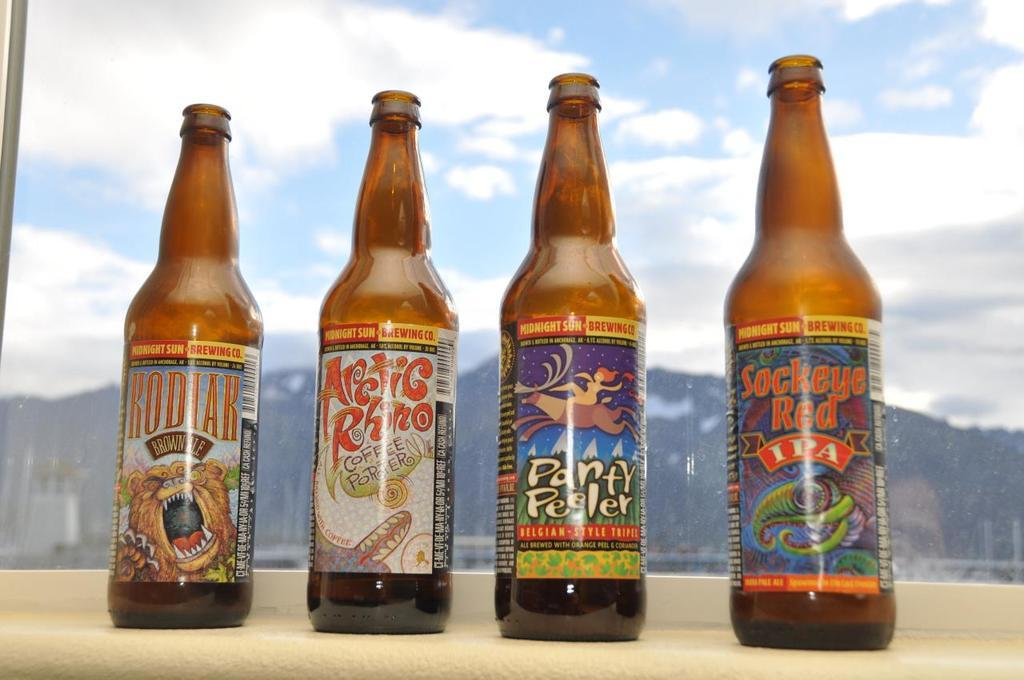<image>
Give a short and clear explanation of the subsequent image. four bottles of alcohol on a window sill with one of them being sockey red ipa 